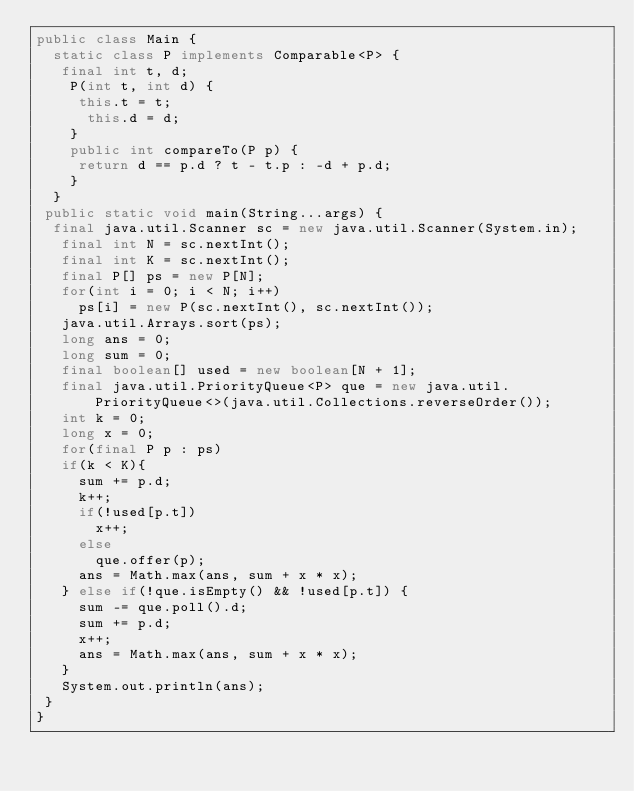<code> <loc_0><loc_0><loc_500><loc_500><_Java_>public class Main {
  static class P implements Comparable<P> {
   final int t, d;
    P(int t, int d) {
     this.t = t;
      this.d = d;
    }
    public int compareTo(P p) {
     return d == p.d ? t - t.p : -d + p.d;
    }
  }
 public static void main(String...args) {
  final java.util.Scanner sc = new java.util.Scanner(System.in);
   final int N = sc.nextInt();
   final int K = sc.nextInt();
   final P[] ps = new P[N];
   for(int i = 0; i < N; i++)
     ps[i] = new P(sc.nextInt(), sc.nextInt());
   java.util.Arrays.sort(ps);
   long ans = 0;
   long sum = 0;
   final boolean[] used = new boolean[N + 1];
   final java.util.PriorityQueue<P> que = new java.util.PriorityQueue<>(java.util.Collections.reverseOrder());
   int k = 0;
   long x = 0;
   for(final P p : ps) 
   if(k < K){
     sum += p.d;
     k++;
     if(!used[p.t])
       x++;
     else
       que.offer(p);
     ans = Math.max(ans, sum + x * x);
   } else if(!que.isEmpty() && !used[p.t]) {
     sum -= que.poll().d;
     sum += p.d;
     x++;
     ans = Math.max(ans, sum + x * x);
   }
   System.out.println(ans);
 }
}</code> 